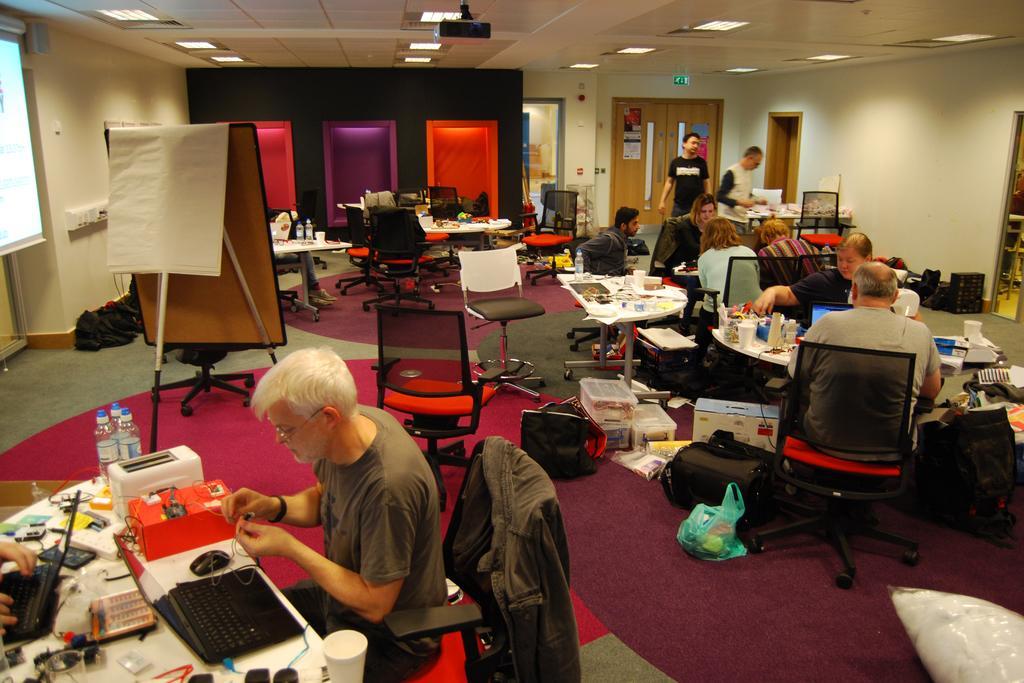Please provide a concise description of this image. This is an indoor picture. In this picture we can see doors, ceiling and lights and also a screen and board. Here we can see persons sitting on chairs in front of a table and they are busy with their works with laptops. This is a floor carpet. On the table we can see bottles, laptops, glasses. On the floor we can see baskets, bags , covers. 